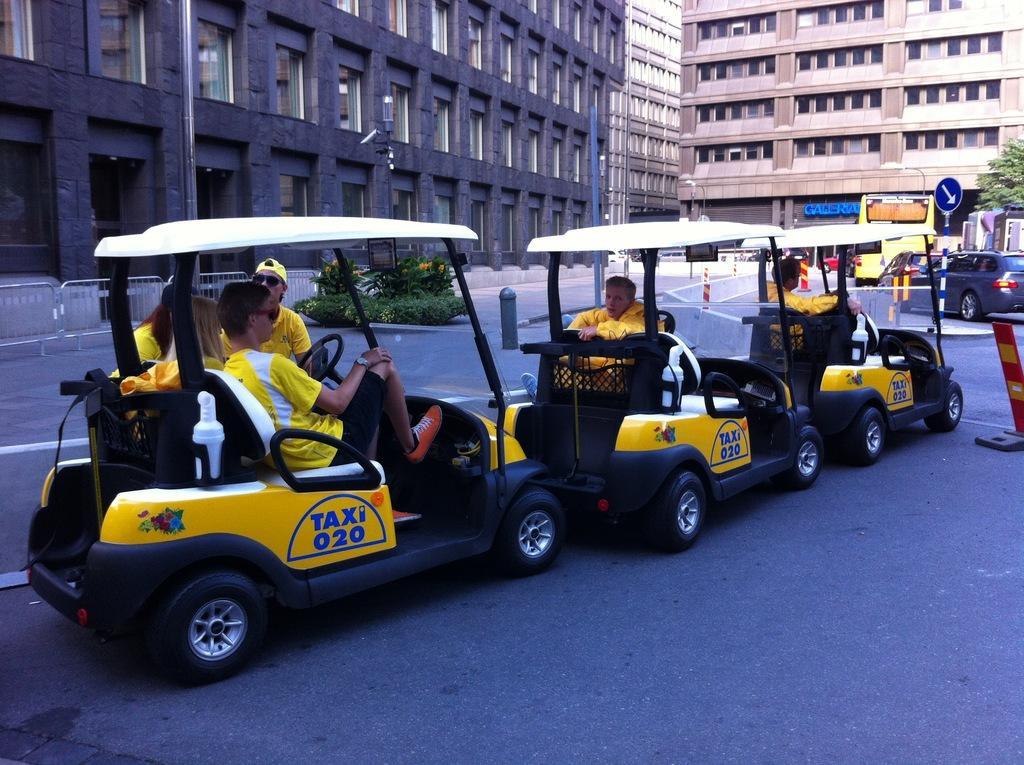Could you give a brief overview of what you see in this image? In the image we can see there are cars parked on the road and people are sitting in it. Behind there are buildings and there is a tree. 